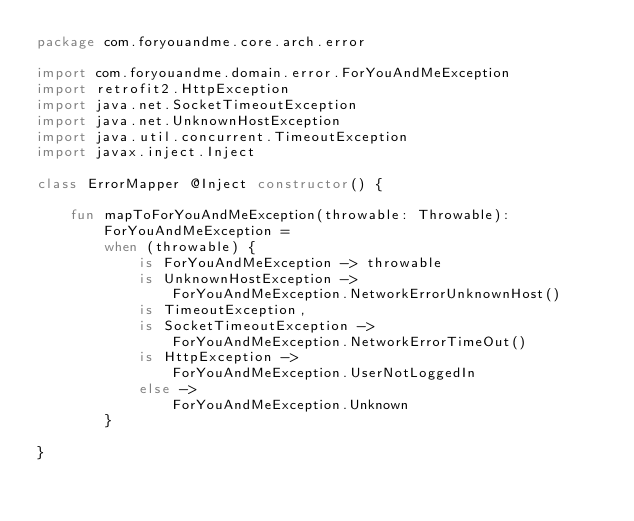Convert code to text. <code><loc_0><loc_0><loc_500><loc_500><_Kotlin_>package com.foryouandme.core.arch.error

import com.foryouandme.domain.error.ForYouAndMeException
import retrofit2.HttpException
import java.net.SocketTimeoutException
import java.net.UnknownHostException
import java.util.concurrent.TimeoutException
import javax.inject.Inject

class ErrorMapper @Inject constructor() {

    fun mapToForYouAndMeException(throwable: Throwable): ForYouAndMeException =
        when (throwable) {
            is ForYouAndMeException -> throwable
            is UnknownHostException ->
                ForYouAndMeException.NetworkErrorUnknownHost()
            is TimeoutException,
            is SocketTimeoutException ->
                ForYouAndMeException.NetworkErrorTimeOut()
            is HttpException ->
                ForYouAndMeException.UserNotLoggedIn
            else ->
                ForYouAndMeException.Unknown
        }

}</code> 